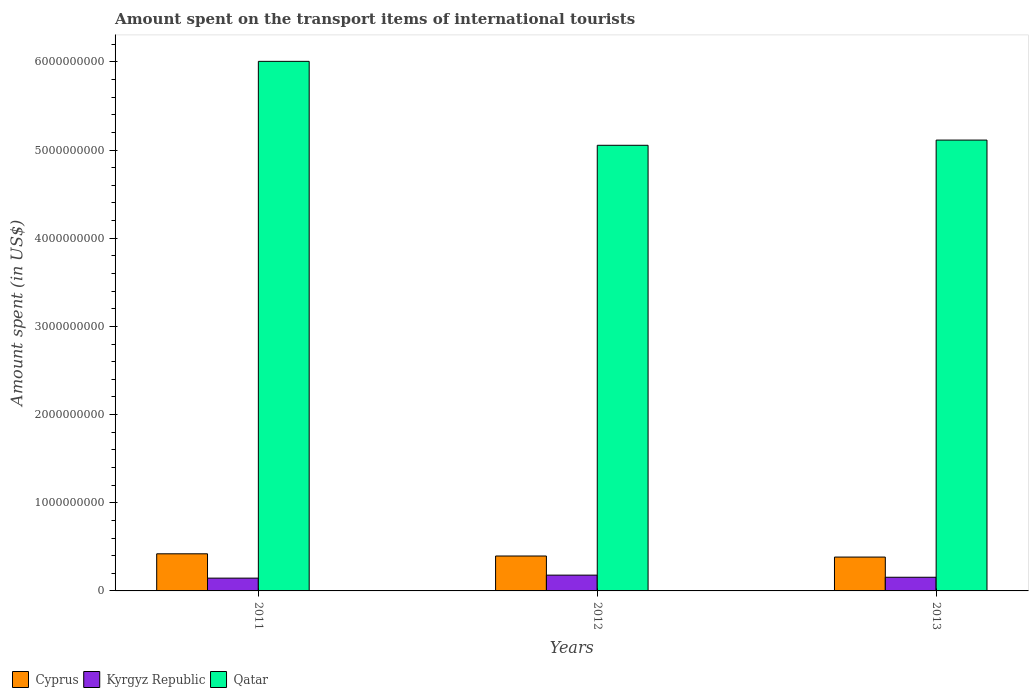How many different coloured bars are there?
Offer a terse response. 3. How many groups of bars are there?
Your answer should be compact. 3. Are the number of bars per tick equal to the number of legend labels?
Make the answer very short. Yes. Are the number of bars on each tick of the X-axis equal?
Your response must be concise. Yes. How many bars are there on the 1st tick from the right?
Offer a very short reply. 3. What is the label of the 1st group of bars from the left?
Keep it short and to the point. 2011. What is the amount spent on the transport items of international tourists in Kyrgyz Republic in 2013?
Offer a terse response. 1.55e+08. Across all years, what is the maximum amount spent on the transport items of international tourists in Cyprus?
Your answer should be compact. 4.21e+08. Across all years, what is the minimum amount spent on the transport items of international tourists in Qatar?
Make the answer very short. 5.05e+09. In which year was the amount spent on the transport items of international tourists in Kyrgyz Republic maximum?
Give a very brief answer. 2012. What is the total amount spent on the transport items of international tourists in Qatar in the graph?
Provide a succinct answer. 1.62e+1. What is the difference between the amount spent on the transport items of international tourists in Kyrgyz Republic in 2012 and that in 2013?
Offer a very short reply. 2.40e+07. What is the difference between the amount spent on the transport items of international tourists in Qatar in 2012 and the amount spent on the transport items of international tourists in Cyprus in 2013?
Give a very brief answer. 4.67e+09. What is the average amount spent on the transport items of international tourists in Cyprus per year?
Offer a terse response. 4.00e+08. In the year 2013, what is the difference between the amount spent on the transport items of international tourists in Qatar and amount spent on the transport items of international tourists in Cyprus?
Give a very brief answer. 4.73e+09. What is the ratio of the amount spent on the transport items of international tourists in Qatar in 2011 to that in 2012?
Offer a terse response. 1.19. Is the amount spent on the transport items of international tourists in Qatar in 2011 less than that in 2012?
Offer a terse response. No. Is the difference between the amount spent on the transport items of international tourists in Qatar in 2011 and 2012 greater than the difference between the amount spent on the transport items of international tourists in Cyprus in 2011 and 2012?
Provide a succinct answer. Yes. What is the difference between the highest and the second highest amount spent on the transport items of international tourists in Qatar?
Offer a terse response. 8.93e+08. What is the difference between the highest and the lowest amount spent on the transport items of international tourists in Kyrgyz Republic?
Keep it short and to the point. 3.40e+07. Is the sum of the amount spent on the transport items of international tourists in Kyrgyz Republic in 2012 and 2013 greater than the maximum amount spent on the transport items of international tourists in Cyprus across all years?
Provide a succinct answer. No. What does the 3rd bar from the left in 2012 represents?
Your response must be concise. Qatar. What does the 1st bar from the right in 2013 represents?
Ensure brevity in your answer.  Qatar. Is it the case that in every year, the sum of the amount spent on the transport items of international tourists in Qatar and amount spent on the transport items of international tourists in Cyprus is greater than the amount spent on the transport items of international tourists in Kyrgyz Republic?
Your answer should be very brief. Yes. Are all the bars in the graph horizontal?
Your response must be concise. No. How many years are there in the graph?
Your response must be concise. 3. What is the difference between two consecutive major ticks on the Y-axis?
Offer a very short reply. 1.00e+09. Are the values on the major ticks of Y-axis written in scientific E-notation?
Your answer should be very brief. No. Does the graph contain grids?
Provide a succinct answer. No. How are the legend labels stacked?
Keep it short and to the point. Horizontal. What is the title of the graph?
Your response must be concise. Amount spent on the transport items of international tourists. What is the label or title of the Y-axis?
Ensure brevity in your answer.  Amount spent (in US$). What is the Amount spent (in US$) of Cyprus in 2011?
Make the answer very short. 4.21e+08. What is the Amount spent (in US$) in Kyrgyz Republic in 2011?
Ensure brevity in your answer.  1.45e+08. What is the Amount spent (in US$) of Qatar in 2011?
Your answer should be very brief. 6.01e+09. What is the Amount spent (in US$) in Cyprus in 2012?
Your response must be concise. 3.96e+08. What is the Amount spent (in US$) of Kyrgyz Republic in 2012?
Provide a succinct answer. 1.79e+08. What is the Amount spent (in US$) of Qatar in 2012?
Your response must be concise. 5.05e+09. What is the Amount spent (in US$) of Cyprus in 2013?
Keep it short and to the point. 3.84e+08. What is the Amount spent (in US$) in Kyrgyz Republic in 2013?
Offer a terse response. 1.55e+08. What is the Amount spent (in US$) in Qatar in 2013?
Your answer should be compact. 5.11e+09. Across all years, what is the maximum Amount spent (in US$) of Cyprus?
Your answer should be compact. 4.21e+08. Across all years, what is the maximum Amount spent (in US$) of Kyrgyz Republic?
Make the answer very short. 1.79e+08. Across all years, what is the maximum Amount spent (in US$) in Qatar?
Keep it short and to the point. 6.01e+09. Across all years, what is the minimum Amount spent (in US$) of Cyprus?
Provide a succinct answer. 3.84e+08. Across all years, what is the minimum Amount spent (in US$) of Kyrgyz Republic?
Keep it short and to the point. 1.45e+08. Across all years, what is the minimum Amount spent (in US$) in Qatar?
Give a very brief answer. 5.05e+09. What is the total Amount spent (in US$) of Cyprus in the graph?
Provide a succinct answer. 1.20e+09. What is the total Amount spent (in US$) of Kyrgyz Republic in the graph?
Ensure brevity in your answer.  4.79e+08. What is the total Amount spent (in US$) in Qatar in the graph?
Your answer should be compact. 1.62e+1. What is the difference between the Amount spent (in US$) of Cyprus in 2011 and that in 2012?
Your answer should be compact. 2.50e+07. What is the difference between the Amount spent (in US$) in Kyrgyz Republic in 2011 and that in 2012?
Keep it short and to the point. -3.40e+07. What is the difference between the Amount spent (in US$) in Qatar in 2011 and that in 2012?
Give a very brief answer. 9.52e+08. What is the difference between the Amount spent (in US$) in Cyprus in 2011 and that in 2013?
Make the answer very short. 3.70e+07. What is the difference between the Amount spent (in US$) of Kyrgyz Republic in 2011 and that in 2013?
Offer a terse response. -1.00e+07. What is the difference between the Amount spent (in US$) of Qatar in 2011 and that in 2013?
Provide a short and direct response. 8.93e+08. What is the difference between the Amount spent (in US$) in Cyprus in 2012 and that in 2013?
Provide a short and direct response. 1.20e+07. What is the difference between the Amount spent (in US$) in Kyrgyz Republic in 2012 and that in 2013?
Your answer should be compact. 2.40e+07. What is the difference between the Amount spent (in US$) of Qatar in 2012 and that in 2013?
Your answer should be very brief. -5.90e+07. What is the difference between the Amount spent (in US$) in Cyprus in 2011 and the Amount spent (in US$) in Kyrgyz Republic in 2012?
Your answer should be very brief. 2.42e+08. What is the difference between the Amount spent (in US$) in Cyprus in 2011 and the Amount spent (in US$) in Qatar in 2012?
Ensure brevity in your answer.  -4.63e+09. What is the difference between the Amount spent (in US$) in Kyrgyz Republic in 2011 and the Amount spent (in US$) in Qatar in 2012?
Provide a short and direct response. -4.91e+09. What is the difference between the Amount spent (in US$) of Cyprus in 2011 and the Amount spent (in US$) of Kyrgyz Republic in 2013?
Ensure brevity in your answer.  2.66e+08. What is the difference between the Amount spent (in US$) in Cyprus in 2011 and the Amount spent (in US$) in Qatar in 2013?
Offer a terse response. -4.69e+09. What is the difference between the Amount spent (in US$) in Kyrgyz Republic in 2011 and the Amount spent (in US$) in Qatar in 2013?
Make the answer very short. -4.97e+09. What is the difference between the Amount spent (in US$) of Cyprus in 2012 and the Amount spent (in US$) of Kyrgyz Republic in 2013?
Offer a terse response. 2.41e+08. What is the difference between the Amount spent (in US$) in Cyprus in 2012 and the Amount spent (in US$) in Qatar in 2013?
Your answer should be very brief. -4.72e+09. What is the difference between the Amount spent (in US$) of Kyrgyz Republic in 2012 and the Amount spent (in US$) of Qatar in 2013?
Your answer should be compact. -4.93e+09. What is the average Amount spent (in US$) of Cyprus per year?
Offer a very short reply. 4.00e+08. What is the average Amount spent (in US$) in Kyrgyz Republic per year?
Provide a succinct answer. 1.60e+08. What is the average Amount spent (in US$) in Qatar per year?
Make the answer very short. 5.39e+09. In the year 2011, what is the difference between the Amount spent (in US$) in Cyprus and Amount spent (in US$) in Kyrgyz Republic?
Offer a terse response. 2.76e+08. In the year 2011, what is the difference between the Amount spent (in US$) of Cyprus and Amount spent (in US$) of Qatar?
Your response must be concise. -5.58e+09. In the year 2011, what is the difference between the Amount spent (in US$) in Kyrgyz Republic and Amount spent (in US$) in Qatar?
Offer a terse response. -5.86e+09. In the year 2012, what is the difference between the Amount spent (in US$) in Cyprus and Amount spent (in US$) in Kyrgyz Republic?
Your response must be concise. 2.17e+08. In the year 2012, what is the difference between the Amount spent (in US$) in Cyprus and Amount spent (in US$) in Qatar?
Your response must be concise. -4.66e+09. In the year 2012, what is the difference between the Amount spent (in US$) in Kyrgyz Republic and Amount spent (in US$) in Qatar?
Provide a succinct answer. -4.88e+09. In the year 2013, what is the difference between the Amount spent (in US$) of Cyprus and Amount spent (in US$) of Kyrgyz Republic?
Make the answer very short. 2.29e+08. In the year 2013, what is the difference between the Amount spent (in US$) of Cyprus and Amount spent (in US$) of Qatar?
Provide a short and direct response. -4.73e+09. In the year 2013, what is the difference between the Amount spent (in US$) of Kyrgyz Republic and Amount spent (in US$) of Qatar?
Provide a succinct answer. -4.96e+09. What is the ratio of the Amount spent (in US$) in Cyprus in 2011 to that in 2012?
Keep it short and to the point. 1.06. What is the ratio of the Amount spent (in US$) of Kyrgyz Republic in 2011 to that in 2012?
Your response must be concise. 0.81. What is the ratio of the Amount spent (in US$) of Qatar in 2011 to that in 2012?
Ensure brevity in your answer.  1.19. What is the ratio of the Amount spent (in US$) in Cyprus in 2011 to that in 2013?
Give a very brief answer. 1.1. What is the ratio of the Amount spent (in US$) in Kyrgyz Republic in 2011 to that in 2013?
Offer a very short reply. 0.94. What is the ratio of the Amount spent (in US$) in Qatar in 2011 to that in 2013?
Make the answer very short. 1.17. What is the ratio of the Amount spent (in US$) of Cyprus in 2012 to that in 2013?
Your answer should be compact. 1.03. What is the ratio of the Amount spent (in US$) in Kyrgyz Republic in 2012 to that in 2013?
Your response must be concise. 1.15. What is the ratio of the Amount spent (in US$) of Qatar in 2012 to that in 2013?
Keep it short and to the point. 0.99. What is the difference between the highest and the second highest Amount spent (in US$) of Cyprus?
Make the answer very short. 2.50e+07. What is the difference between the highest and the second highest Amount spent (in US$) in Kyrgyz Republic?
Offer a terse response. 2.40e+07. What is the difference between the highest and the second highest Amount spent (in US$) in Qatar?
Your response must be concise. 8.93e+08. What is the difference between the highest and the lowest Amount spent (in US$) of Cyprus?
Your answer should be compact. 3.70e+07. What is the difference between the highest and the lowest Amount spent (in US$) of Kyrgyz Republic?
Your answer should be very brief. 3.40e+07. What is the difference between the highest and the lowest Amount spent (in US$) of Qatar?
Your answer should be compact. 9.52e+08. 